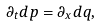Convert formula to latex. <formula><loc_0><loc_0><loc_500><loc_500>\partial _ { t } d p = \partial _ { x } d q ,</formula> 